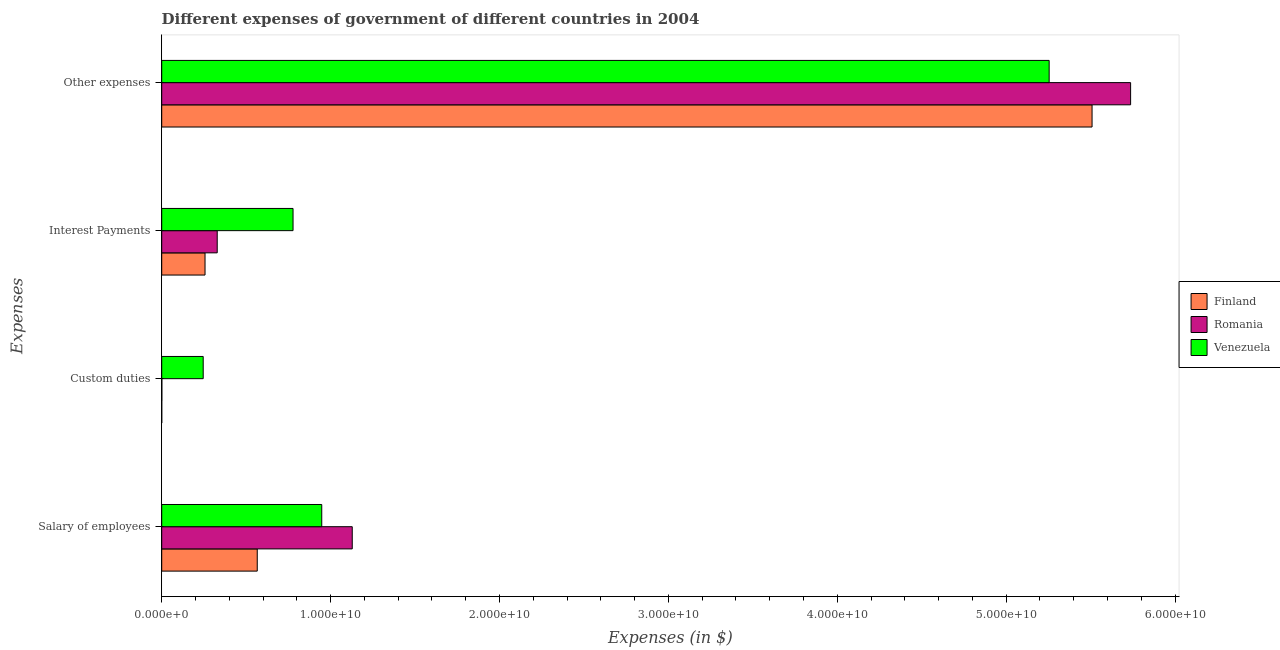How many different coloured bars are there?
Keep it short and to the point. 3. How many groups of bars are there?
Your response must be concise. 4. Are the number of bars per tick equal to the number of legend labels?
Give a very brief answer. Yes. How many bars are there on the 2nd tick from the top?
Provide a short and direct response. 3. How many bars are there on the 4th tick from the bottom?
Your answer should be very brief. 3. What is the label of the 3rd group of bars from the top?
Offer a terse response. Custom duties. What is the amount spent on custom duties in Venezuela?
Your answer should be compact. 2.46e+09. Across all countries, what is the maximum amount spent on interest payments?
Offer a terse response. 7.78e+09. Across all countries, what is the minimum amount spent on other expenses?
Keep it short and to the point. 5.25e+1. In which country was the amount spent on interest payments maximum?
Keep it short and to the point. Venezuela. In which country was the amount spent on custom duties minimum?
Make the answer very short. Finland. What is the total amount spent on custom duties in the graph?
Offer a very short reply. 2.47e+09. What is the difference between the amount spent on custom duties in Venezuela and that in Romania?
Keep it short and to the point. 2.45e+09. What is the difference between the amount spent on other expenses in Romania and the amount spent on salary of employees in Venezuela?
Keep it short and to the point. 4.79e+1. What is the average amount spent on custom duties per country?
Provide a succinct answer. 8.22e+08. What is the difference between the amount spent on salary of employees and amount spent on other expenses in Romania?
Make the answer very short. -4.61e+1. What is the ratio of the amount spent on interest payments in Venezuela to that in Romania?
Make the answer very short. 2.37. Is the amount spent on custom duties in Romania less than that in Finland?
Make the answer very short. No. What is the difference between the highest and the second highest amount spent on custom duties?
Ensure brevity in your answer.  2.45e+09. What is the difference between the highest and the lowest amount spent on custom duties?
Keep it short and to the point. 2.46e+09. In how many countries, is the amount spent on other expenses greater than the average amount spent on other expenses taken over all countries?
Provide a succinct answer. 2. Is the sum of the amount spent on custom duties in Finland and Venezuela greater than the maximum amount spent on other expenses across all countries?
Offer a terse response. No. How many bars are there?
Your response must be concise. 12. Are all the bars in the graph horizontal?
Offer a very short reply. Yes. How many countries are there in the graph?
Offer a very short reply. 3. Are the values on the major ticks of X-axis written in scientific E-notation?
Your response must be concise. Yes. Does the graph contain any zero values?
Your answer should be compact. No. Does the graph contain grids?
Ensure brevity in your answer.  No. Where does the legend appear in the graph?
Keep it short and to the point. Center right. How many legend labels are there?
Ensure brevity in your answer.  3. How are the legend labels stacked?
Provide a succinct answer. Vertical. What is the title of the graph?
Make the answer very short. Different expenses of government of different countries in 2004. What is the label or title of the X-axis?
Your response must be concise. Expenses (in $). What is the label or title of the Y-axis?
Provide a short and direct response. Expenses. What is the Expenses (in $) of Finland in Salary of employees?
Offer a very short reply. 5.66e+09. What is the Expenses (in $) of Romania in Salary of employees?
Your answer should be very brief. 1.13e+1. What is the Expenses (in $) of Venezuela in Salary of employees?
Your response must be concise. 9.48e+09. What is the Expenses (in $) in Finland in Custom duties?
Offer a terse response. 1.00e+06. What is the Expenses (in $) in Romania in Custom duties?
Offer a very short reply. 7.91e+06. What is the Expenses (in $) in Venezuela in Custom duties?
Your response must be concise. 2.46e+09. What is the Expenses (in $) in Finland in Interest Payments?
Provide a succinct answer. 2.56e+09. What is the Expenses (in $) of Romania in Interest Payments?
Make the answer very short. 3.29e+09. What is the Expenses (in $) of Venezuela in Interest Payments?
Provide a short and direct response. 7.78e+09. What is the Expenses (in $) in Finland in Other expenses?
Make the answer very short. 5.51e+1. What is the Expenses (in $) in Romania in Other expenses?
Your response must be concise. 5.74e+1. What is the Expenses (in $) in Venezuela in Other expenses?
Provide a short and direct response. 5.25e+1. Across all Expenses, what is the maximum Expenses (in $) in Finland?
Give a very brief answer. 5.51e+1. Across all Expenses, what is the maximum Expenses (in $) in Romania?
Offer a terse response. 5.74e+1. Across all Expenses, what is the maximum Expenses (in $) of Venezuela?
Make the answer very short. 5.25e+1. Across all Expenses, what is the minimum Expenses (in $) in Finland?
Your response must be concise. 1.00e+06. Across all Expenses, what is the minimum Expenses (in $) of Romania?
Your response must be concise. 7.91e+06. Across all Expenses, what is the minimum Expenses (in $) in Venezuela?
Your answer should be very brief. 2.46e+09. What is the total Expenses (in $) in Finland in the graph?
Provide a short and direct response. 6.33e+1. What is the total Expenses (in $) of Romania in the graph?
Your response must be concise. 7.19e+1. What is the total Expenses (in $) in Venezuela in the graph?
Give a very brief answer. 7.23e+1. What is the difference between the Expenses (in $) of Finland in Salary of employees and that in Custom duties?
Offer a terse response. 5.66e+09. What is the difference between the Expenses (in $) in Romania in Salary of employees and that in Custom duties?
Give a very brief answer. 1.13e+1. What is the difference between the Expenses (in $) of Venezuela in Salary of employees and that in Custom duties?
Make the answer very short. 7.02e+09. What is the difference between the Expenses (in $) in Finland in Salary of employees and that in Interest Payments?
Offer a very short reply. 3.09e+09. What is the difference between the Expenses (in $) in Romania in Salary of employees and that in Interest Payments?
Offer a terse response. 8.00e+09. What is the difference between the Expenses (in $) of Venezuela in Salary of employees and that in Interest Payments?
Keep it short and to the point. 1.70e+09. What is the difference between the Expenses (in $) of Finland in Salary of employees and that in Other expenses?
Make the answer very short. -4.94e+1. What is the difference between the Expenses (in $) of Romania in Salary of employees and that in Other expenses?
Make the answer very short. -4.61e+1. What is the difference between the Expenses (in $) in Venezuela in Salary of employees and that in Other expenses?
Provide a succinct answer. -4.31e+1. What is the difference between the Expenses (in $) of Finland in Custom duties and that in Interest Payments?
Ensure brevity in your answer.  -2.56e+09. What is the difference between the Expenses (in $) of Romania in Custom duties and that in Interest Payments?
Your answer should be very brief. -3.28e+09. What is the difference between the Expenses (in $) of Venezuela in Custom duties and that in Interest Payments?
Ensure brevity in your answer.  -5.32e+09. What is the difference between the Expenses (in $) in Finland in Custom duties and that in Other expenses?
Your response must be concise. -5.51e+1. What is the difference between the Expenses (in $) in Romania in Custom duties and that in Other expenses?
Keep it short and to the point. -5.74e+1. What is the difference between the Expenses (in $) of Venezuela in Custom duties and that in Other expenses?
Provide a succinct answer. -5.01e+1. What is the difference between the Expenses (in $) in Finland in Interest Payments and that in Other expenses?
Keep it short and to the point. -5.25e+1. What is the difference between the Expenses (in $) of Romania in Interest Payments and that in Other expenses?
Provide a short and direct response. -5.41e+1. What is the difference between the Expenses (in $) in Venezuela in Interest Payments and that in Other expenses?
Ensure brevity in your answer.  -4.48e+1. What is the difference between the Expenses (in $) in Finland in Salary of employees and the Expenses (in $) in Romania in Custom duties?
Offer a very short reply. 5.65e+09. What is the difference between the Expenses (in $) in Finland in Salary of employees and the Expenses (in $) in Venezuela in Custom duties?
Your answer should be compact. 3.20e+09. What is the difference between the Expenses (in $) of Romania in Salary of employees and the Expenses (in $) of Venezuela in Custom duties?
Offer a terse response. 8.83e+09. What is the difference between the Expenses (in $) of Finland in Salary of employees and the Expenses (in $) of Romania in Interest Payments?
Your response must be concise. 2.37e+09. What is the difference between the Expenses (in $) in Finland in Salary of employees and the Expenses (in $) in Venezuela in Interest Payments?
Give a very brief answer. -2.12e+09. What is the difference between the Expenses (in $) of Romania in Salary of employees and the Expenses (in $) of Venezuela in Interest Payments?
Give a very brief answer. 3.51e+09. What is the difference between the Expenses (in $) in Finland in Salary of employees and the Expenses (in $) in Romania in Other expenses?
Provide a succinct answer. -5.17e+1. What is the difference between the Expenses (in $) of Finland in Salary of employees and the Expenses (in $) of Venezuela in Other expenses?
Provide a succinct answer. -4.69e+1. What is the difference between the Expenses (in $) in Romania in Salary of employees and the Expenses (in $) in Venezuela in Other expenses?
Provide a short and direct response. -4.13e+1. What is the difference between the Expenses (in $) in Finland in Custom duties and the Expenses (in $) in Romania in Interest Payments?
Offer a very short reply. -3.29e+09. What is the difference between the Expenses (in $) of Finland in Custom duties and the Expenses (in $) of Venezuela in Interest Payments?
Offer a very short reply. -7.78e+09. What is the difference between the Expenses (in $) of Romania in Custom duties and the Expenses (in $) of Venezuela in Interest Payments?
Offer a terse response. -7.77e+09. What is the difference between the Expenses (in $) in Finland in Custom duties and the Expenses (in $) in Romania in Other expenses?
Provide a short and direct response. -5.74e+1. What is the difference between the Expenses (in $) in Finland in Custom duties and the Expenses (in $) in Venezuela in Other expenses?
Offer a terse response. -5.25e+1. What is the difference between the Expenses (in $) of Romania in Custom duties and the Expenses (in $) of Venezuela in Other expenses?
Offer a terse response. -5.25e+1. What is the difference between the Expenses (in $) of Finland in Interest Payments and the Expenses (in $) of Romania in Other expenses?
Provide a succinct answer. -5.48e+1. What is the difference between the Expenses (in $) in Finland in Interest Payments and the Expenses (in $) in Venezuela in Other expenses?
Your response must be concise. -5.00e+1. What is the difference between the Expenses (in $) of Romania in Interest Payments and the Expenses (in $) of Venezuela in Other expenses?
Your response must be concise. -4.93e+1. What is the average Expenses (in $) in Finland per Expenses?
Your answer should be very brief. 1.58e+1. What is the average Expenses (in $) of Romania per Expenses?
Keep it short and to the point. 1.80e+1. What is the average Expenses (in $) in Venezuela per Expenses?
Provide a short and direct response. 1.81e+1. What is the difference between the Expenses (in $) in Finland and Expenses (in $) in Romania in Salary of employees?
Give a very brief answer. -5.63e+09. What is the difference between the Expenses (in $) of Finland and Expenses (in $) of Venezuela in Salary of employees?
Keep it short and to the point. -3.82e+09. What is the difference between the Expenses (in $) in Romania and Expenses (in $) in Venezuela in Salary of employees?
Give a very brief answer. 1.81e+09. What is the difference between the Expenses (in $) of Finland and Expenses (in $) of Romania in Custom duties?
Offer a very short reply. -6.91e+06. What is the difference between the Expenses (in $) of Finland and Expenses (in $) of Venezuela in Custom duties?
Ensure brevity in your answer.  -2.46e+09. What is the difference between the Expenses (in $) of Romania and Expenses (in $) of Venezuela in Custom duties?
Offer a terse response. -2.45e+09. What is the difference between the Expenses (in $) in Finland and Expenses (in $) in Romania in Interest Payments?
Your response must be concise. -7.22e+08. What is the difference between the Expenses (in $) of Finland and Expenses (in $) of Venezuela in Interest Payments?
Offer a terse response. -5.21e+09. What is the difference between the Expenses (in $) in Romania and Expenses (in $) in Venezuela in Interest Payments?
Make the answer very short. -4.49e+09. What is the difference between the Expenses (in $) of Finland and Expenses (in $) of Romania in Other expenses?
Provide a short and direct response. -2.28e+09. What is the difference between the Expenses (in $) of Finland and Expenses (in $) of Venezuela in Other expenses?
Your answer should be very brief. 2.54e+09. What is the difference between the Expenses (in $) of Romania and Expenses (in $) of Venezuela in Other expenses?
Keep it short and to the point. 4.82e+09. What is the ratio of the Expenses (in $) of Finland in Salary of employees to that in Custom duties?
Give a very brief answer. 5657. What is the ratio of the Expenses (in $) in Romania in Salary of employees to that in Custom duties?
Your answer should be very brief. 1425.77. What is the ratio of the Expenses (in $) in Venezuela in Salary of employees to that in Custom duties?
Offer a very short reply. 3.86. What is the ratio of the Expenses (in $) of Finland in Salary of employees to that in Interest Payments?
Keep it short and to the point. 2.21. What is the ratio of the Expenses (in $) in Romania in Salary of employees to that in Interest Payments?
Give a very brief answer. 3.43. What is the ratio of the Expenses (in $) in Venezuela in Salary of employees to that in Interest Payments?
Ensure brevity in your answer.  1.22. What is the ratio of the Expenses (in $) of Finland in Salary of employees to that in Other expenses?
Ensure brevity in your answer.  0.1. What is the ratio of the Expenses (in $) of Romania in Salary of employees to that in Other expenses?
Provide a short and direct response. 0.2. What is the ratio of the Expenses (in $) of Venezuela in Salary of employees to that in Other expenses?
Give a very brief answer. 0.18. What is the ratio of the Expenses (in $) in Romania in Custom duties to that in Interest Payments?
Provide a succinct answer. 0. What is the ratio of the Expenses (in $) of Venezuela in Custom duties to that in Interest Payments?
Make the answer very short. 0.32. What is the ratio of the Expenses (in $) in Romania in Custom duties to that in Other expenses?
Provide a succinct answer. 0. What is the ratio of the Expenses (in $) in Venezuela in Custom duties to that in Other expenses?
Ensure brevity in your answer.  0.05. What is the ratio of the Expenses (in $) of Finland in Interest Payments to that in Other expenses?
Offer a very short reply. 0.05. What is the ratio of the Expenses (in $) in Romania in Interest Payments to that in Other expenses?
Ensure brevity in your answer.  0.06. What is the ratio of the Expenses (in $) of Venezuela in Interest Payments to that in Other expenses?
Offer a very short reply. 0.15. What is the difference between the highest and the second highest Expenses (in $) of Finland?
Your answer should be compact. 4.94e+1. What is the difference between the highest and the second highest Expenses (in $) of Romania?
Provide a short and direct response. 4.61e+1. What is the difference between the highest and the second highest Expenses (in $) in Venezuela?
Ensure brevity in your answer.  4.31e+1. What is the difference between the highest and the lowest Expenses (in $) in Finland?
Offer a terse response. 5.51e+1. What is the difference between the highest and the lowest Expenses (in $) of Romania?
Your answer should be very brief. 5.74e+1. What is the difference between the highest and the lowest Expenses (in $) of Venezuela?
Your answer should be compact. 5.01e+1. 